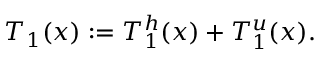Convert formula to latex. <formula><loc_0><loc_0><loc_500><loc_500>T _ { 1 } ( x ) \colon = T _ { 1 } ^ { h } ( x ) + T _ { 1 } ^ { u } ( x ) .</formula> 